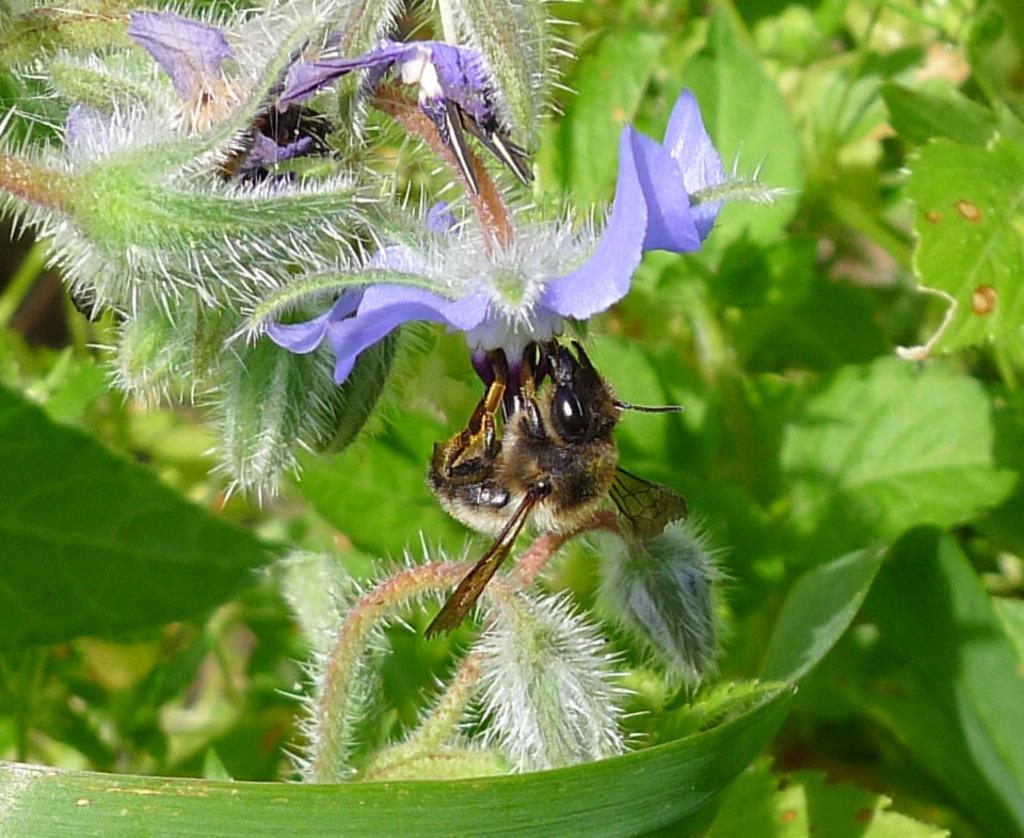What is present in the picture that is small and has multiple legs? There is an insect in the picture. What is the insect resting on or interacting with in the picture? The insect is on an object. What type of natural elements can be seen in the background of the picture? There are leaves in the background of the picture. What type of song is the insect singing in the picture? There is no indication in the image that the insect is singing a song, as insects do not have the ability to sing. 